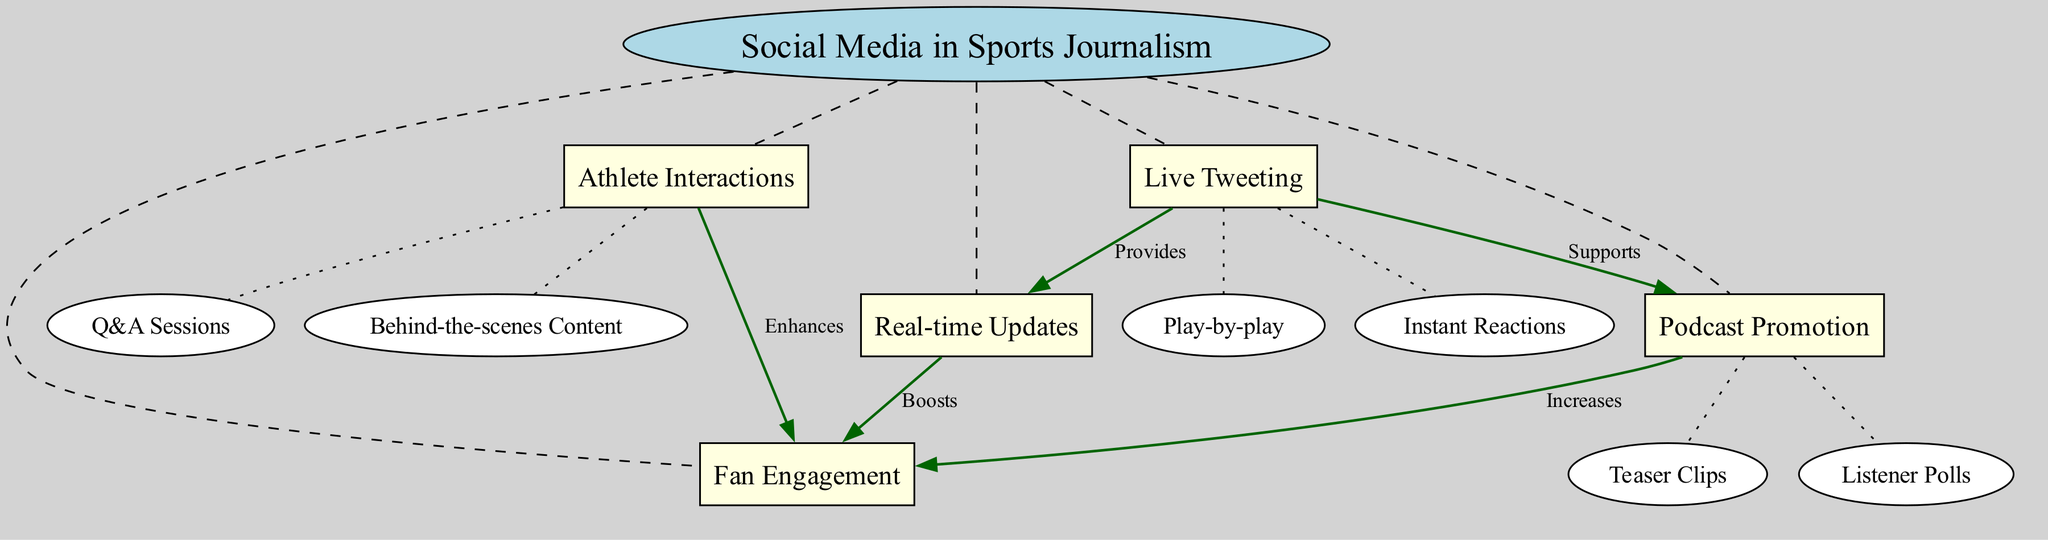What is the central concept of the diagram? The central concept is stated at the top of the diagram. It is clearly labeled as "Social Media in Sports Journalism".
Answer: Social Media in Sports Journalism How many main nodes are there in the diagram? The diagram includes five main nodes, which are listed around the central concept. These nodes are Live Tweeting, Athlete Interactions, Real-time Updates, Fan Engagement, and Podcast Promotion.
Answer: 5 What relationship does Live Tweeting have with Real-time Updates? The connections between nodes are labeled, and Live Tweeting is shown to provide Real-time Updates in the diagram. This connection is indicated with an arrow and label between the two nodes.
Answer: Provides Which main node enhances Fan Engagement? The connection from Athlete Interactions leads to Fan Engagement, and it is labeled as enhances. This indicates that Athlete Interactions play a role in making fan engagement stronger.
Answer: Athlete Interactions What type of content is associated with Athlete Interactions? The sub-nodes under Athlete Interactions include Q&A Sessions and Behind-the-scenes Content. These are the specific types of content that relate to the main node.
Answer: Q&A Sessions, Behind-the-scenes Content Which nodes are connected with a supporting relationship? The diagram shows that Live Tweeting supports Podcast Promotion. This relationship is represented by an arrow and a supporting label.
Answer: Podcast Promotion What is the effect of Real-time Updates on Fan Engagement? The diagram indicates that Real-time Updates boosts Fan Engagement, establishing a direct relationship between these two concepts.
Answer: Boosts How are Podcast Promotion and Fan Engagement related? The connection shows that Podcast Promotion increases Fan Engagement, meaning that promoting podcasts positively affects how fans engage.
Answer: Increases What are the two types of sub-nodes under Live Tweeting? For Live Tweeting, the sub-nodes are classified as Play-by-play and Instant Reactions, which detail the kinds of content generated under this main node.
Answer: Play-by-play, Instant Reactions 